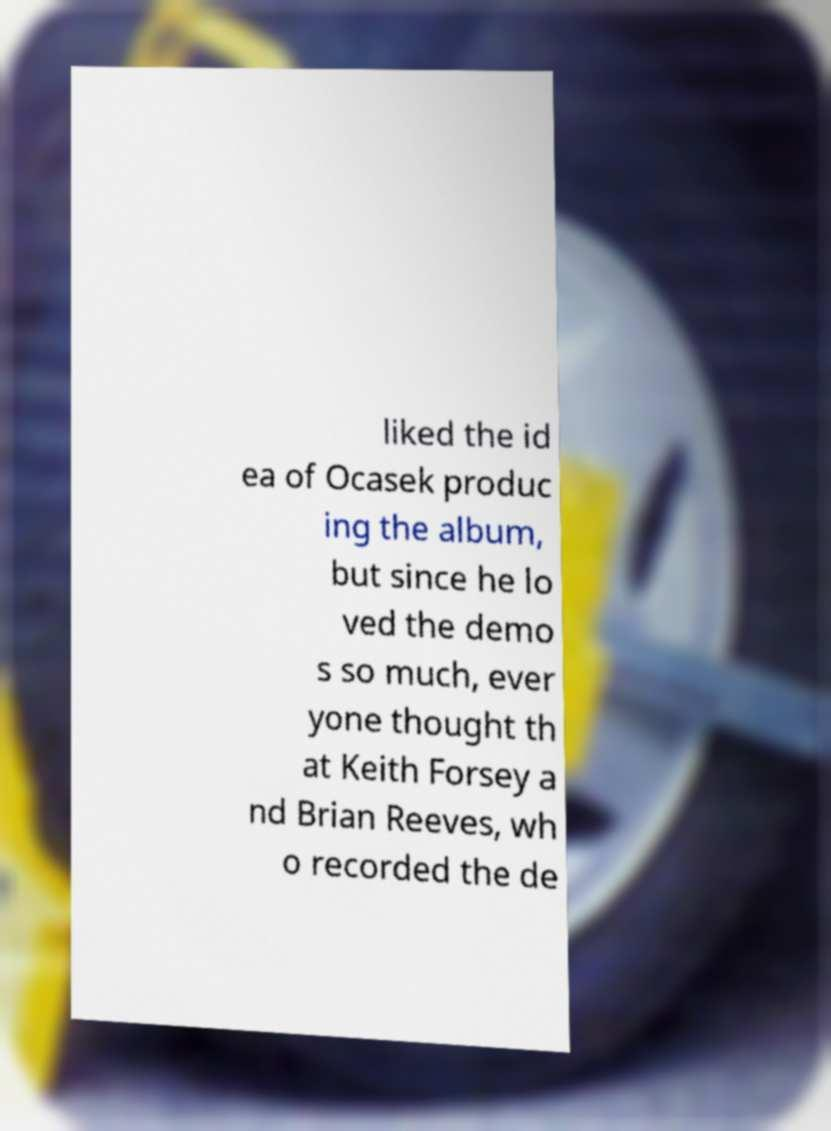There's text embedded in this image that I need extracted. Can you transcribe it verbatim? liked the id ea of Ocasek produc ing the album, but since he lo ved the demo s so much, ever yone thought th at Keith Forsey a nd Brian Reeves, wh o recorded the de 